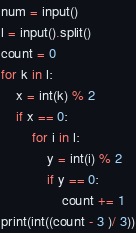Convert code to text. <code><loc_0><loc_0><loc_500><loc_500><_Python_>num = input()
l = input().split()
count = 0
for k in l:
    x = int(k) % 2
    if x == 0:
        for i in l:
            y = int(i) % 2 
            if y == 0:
                count += 1
print(int((count - 3 )/ 3))</code> 